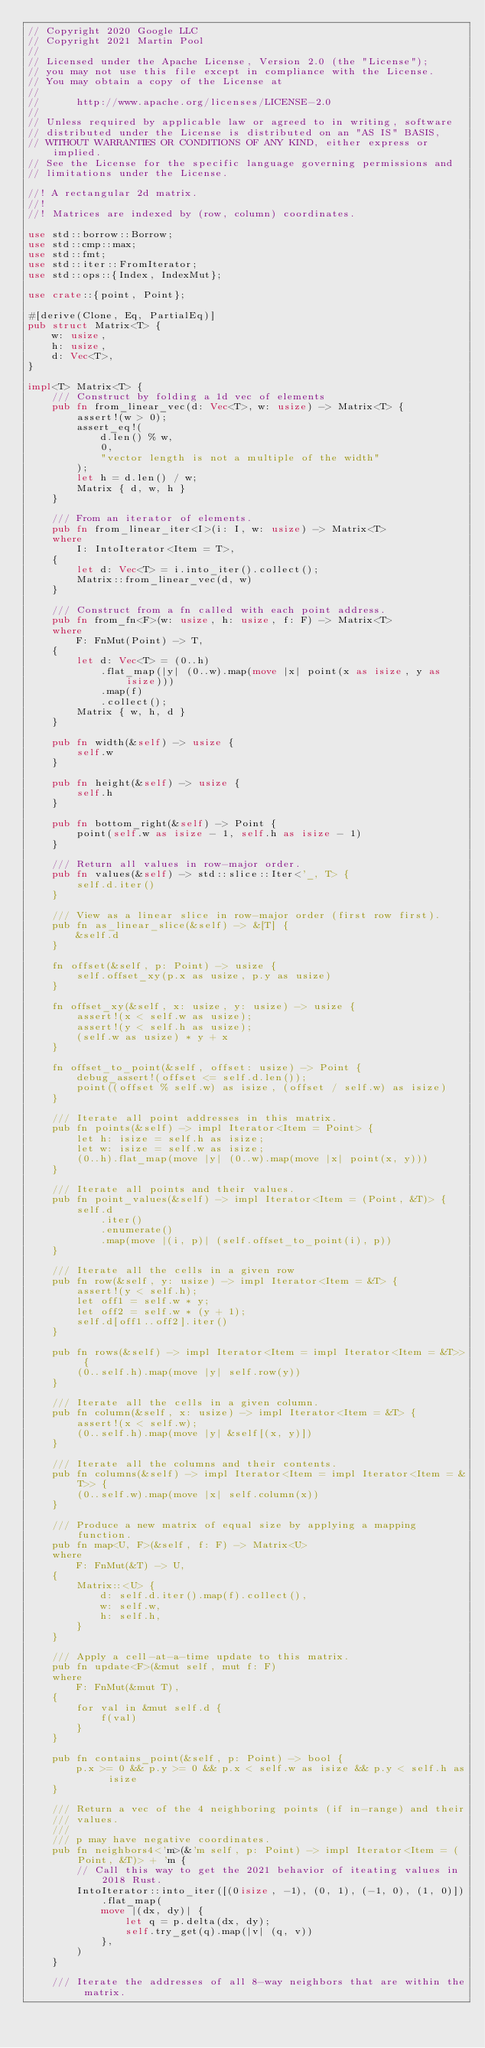<code> <loc_0><loc_0><loc_500><loc_500><_Rust_>// Copyright 2020 Google LLC
// Copyright 2021 Martin Pool
//
// Licensed under the Apache License, Version 2.0 (the "License");
// you may not use this file except in compliance with the License.
// You may obtain a copy of the License at
//
//      http://www.apache.org/licenses/LICENSE-2.0
//
// Unless required by applicable law or agreed to in writing, software
// distributed under the License is distributed on an "AS IS" BASIS,
// WITHOUT WARRANTIES OR CONDITIONS OF ANY KIND, either express or implied.
// See the License for the specific language governing permissions and
// limitations under the License.

//! A rectangular 2d matrix.
//!
//! Matrices are indexed by (row, column) coordinates.

use std::borrow::Borrow;
use std::cmp::max;
use std::fmt;
use std::iter::FromIterator;
use std::ops::{Index, IndexMut};

use crate::{point, Point};

#[derive(Clone, Eq, PartialEq)]
pub struct Matrix<T> {
    w: usize,
    h: usize,
    d: Vec<T>,
}

impl<T> Matrix<T> {
    /// Construct by folding a 1d vec of elements
    pub fn from_linear_vec(d: Vec<T>, w: usize) -> Matrix<T> {
        assert!(w > 0);
        assert_eq!(
            d.len() % w,
            0,
            "vector length is not a multiple of the width"
        );
        let h = d.len() / w;
        Matrix { d, w, h }
    }

    /// From an iterator of elements.
    pub fn from_linear_iter<I>(i: I, w: usize) -> Matrix<T>
    where
        I: IntoIterator<Item = T>,
    {
        let d: Vec<T> = i.into_iter().collect();
        Matrix::from_linear_vec(d, w)
    }

    /// Construct from a fn called with each point address.
    pub fn from_fn<F>(w: usize, h: usize, f: F) -> Matrix<T>
    where
        F: FnMut(Point) -> T,
    {
        let d: Vec<T> = (0..h)
            .flat_map(|y| (0..w).map(move |x| point(x as isize, y as isize)))
            .map(f)
            .collect();
        Matrix { w, h, d }
    }

    pub fn width(&self) -> usize {
        self.w
    }

    pub fn height(&self) -> usize {
        self.h
    }

    pub fn bottom_right(&self) -> Point {
        point(self.w as isize - 1, self.h as isize - 1)
    }

    /// Return all values in row-major order.
    pub fn values(&self) -> std::slice::Iter<'_, T> {
        self.d.iter()
    }

    /// View as a linear slice in row-major order (first row first).
    pub fn as_linear_slice(&self) -> &[T] {
        &self.d
    }

    fn offset(&self, p: Point) -> usize {
        self.offset_xy(p.x as usize, p.y as usize)
    }

    fn offset_xy(&self, x: usize, y: usize) -> usize {
        assert!(x < self.w as usize);
        assert!(y < self.h as usize);
        (self.w as usize) * y + x
    }

    fn offset_to_point(&self, offset: usize) -> Point {
        debug_assert!(offset <= self.d.len());
        point((offset % self.w) as isize, (offset / self.w) as isize)
    }

    /// Iterate all point addresses in this matrix.
    pub fn points(&self) -> impl Iterator<Item = Point> {
        let h: isize = self.h as isize;
        let w: isize = self.w as isize;
        (0..h).flat_map(move |y| (0..w).map(move |x| point(x, y)))
    }

    /// Iterate all points and their values.
    pub fn point_values(&self) -> impl Iterator<Item = (Point, &T)> {
        self.d
            .iter()
            .enumerate()
            .map(move |(i, p)| (self.offset_to_point(i), p))
    }

    /// Iterate all the cells in a given row
    pub fn row(&self, y: usize) -> impl Iterator<Item = &T> {
        assert!(y < self.h);
        let off1 = self.w * y;
        let off2 = self.w * (y + 1);
        self.d[off1..off2].iter()
    }

    pub fn rows(&self) -> impl Iterator<Item = impl Iterator<Item = &T>> {
        (0..self.h).map(move |y| self.row(y))
    }

    /// Iterate all the cells in a given column.
    pub fn column(&self, x: usize) -> impl Iterator<Item = &T> {
        assert!(x < self.w);
        (0..self.h).map(move |y| &self[(x, y)])
    }

    /// Iterate all the columns and their contents.
    pub fn columns(&self) -> impl Iterator<Item = impl Iterator<Item = &T>> {
        (0..self.w).map(move |x| self.column(x))
    }

    /// Produce a new matrix of equal size by applying a mapping function.
    pub fn map<U, F>(&self, f: F) -> Matrix<U>
    where
        F: FnMut(&T) -> U,
    {
        Matrix::<U> {
            d: self.d.iter().map(f).collect(),
            w: self.w,
            h: self.h,
        }
    }

    /// Apply a cell-at-a-time update to this matrix.
    pub fn update<F>(&mut self, mut f: F)
    where
        F: FnMut(&mut T),
    {
        for val in &mut self.d {
            f(val)
        }
    }

    pub fn contains_point(&self, p: Point) -> bool {
        p.x >= 0 && p.y >= 0 && p.x < self.w as isize && p.y < self.h as isize
    }

    /// Return a vec of the 4 neighboring points (if in-range) and their
    /// values.
    ///
    /// p may have negative coordinates.
    pub fn neighbors4<'m>(&'m self, p: Point) -> impl Iterator<Item = (Point, &T)> + 'm {
        // Call this way to get the 2021 behavior of iteating values in 2018 Rust.
        IntoIterator::into_iter([(0isize, -1), (0, 1), (-1, 0), (1, 0)]).flat_map(
            move |(dx, dy)| {
                let q = p.delta(dx, dy);
                self.try_get(q).map(|v| (q, v))
            },
        )
    }

    /// Iterate the addresses of all 8-way neighbors that are within the matrix.</code> 